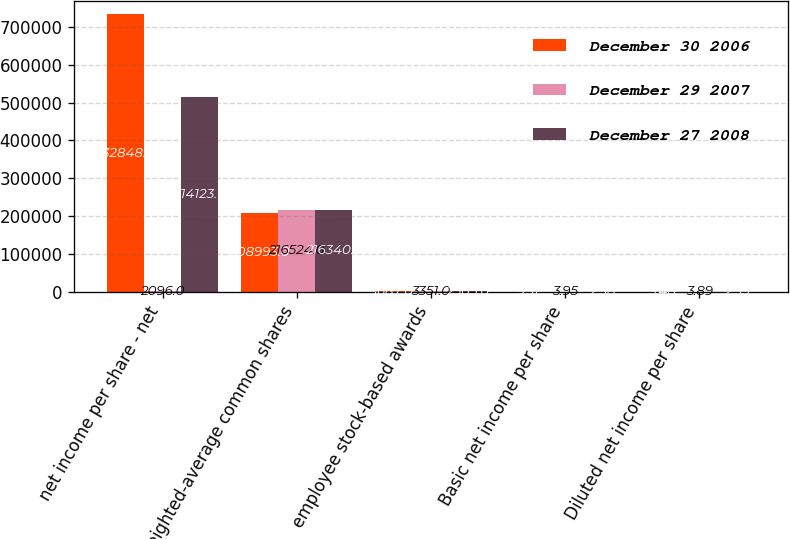Convert chart to OTSL. <chart><loc_0><loc_0><loc_500><loc_500><stacked_bar_chart><ecel><fcel>net income per share - net<fcel>weighted-average common shares<fcel>employee stock-based awards<fcel>Basic net income per share<fcel>Diluted net income per share<nl><fcel>December 30 2006<fcel>732848<fcel>208993<fcel>1687<fcel>3.51<fcel>3.48<nl><fcel>December 29 2007<fcel>2096<fcel>216524<fcel>3351<fcel>3.95<fcel>3.89<nl><fcel>December 27 2008<fcel>514123<fcel>216340<fcel>2505<fcel>2.38<fcel>2.35<nl></chart> 